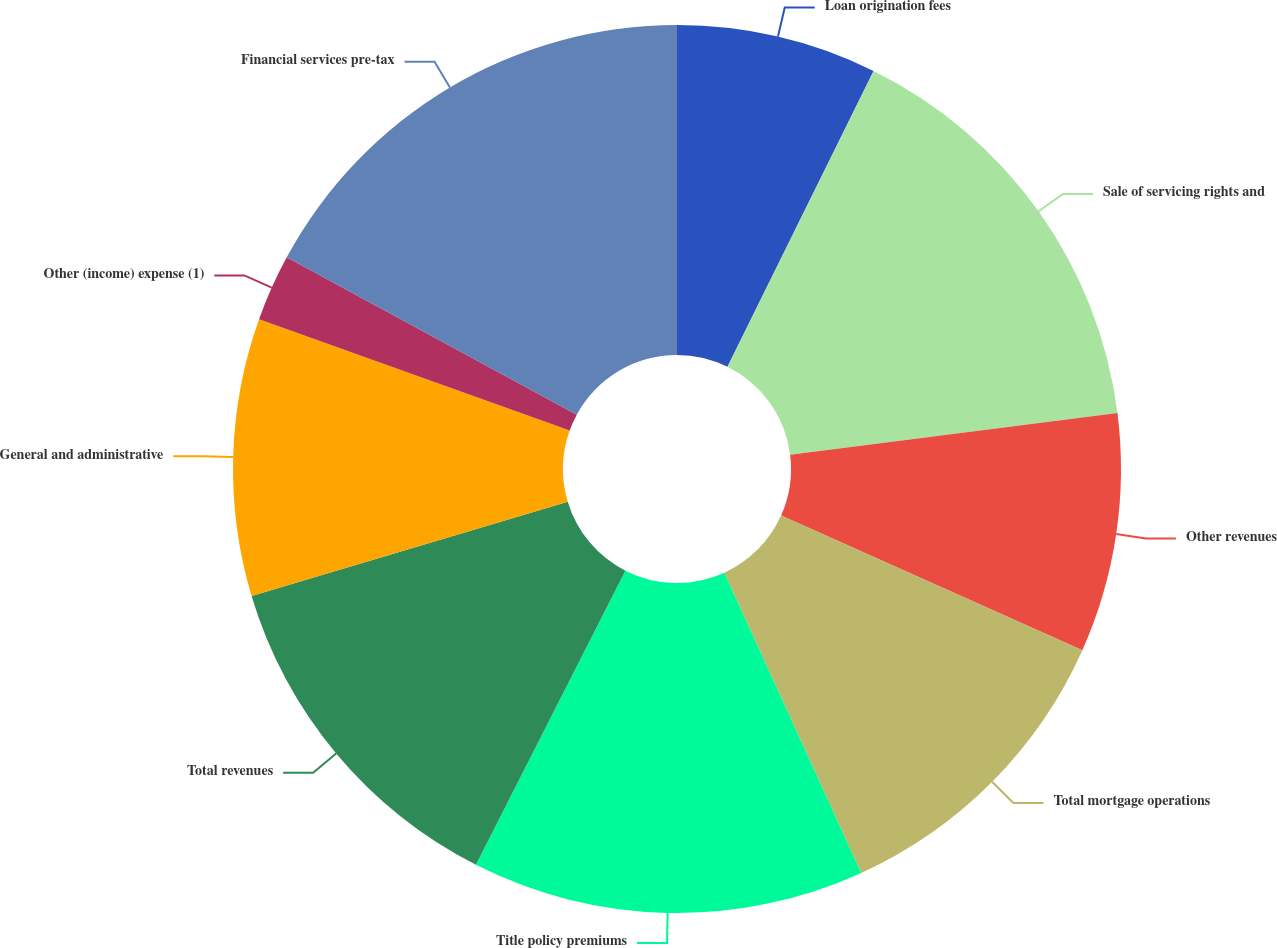<chart> <loc_0><loc_0><loc_500><loc_500><pie_chart><fcel>Loan origination fees<fcel>Sale of servicing rights and<fcel>Other revenues<fcel>Total mortgage operations<fcel>Title policy premiums<fcel>Total revenues<fcel>General and administrative<fcel>Other (income) expense (1)<fcel>Financial services pre-tax<nl><fcel>7.3%<fcel>15.69%<fcel>8.7%<fcel>11.5%<fcel>14.29%<fcel>12.9%<fcel>10.1%<fcel>2.43%<fcel>17.09%<nl></chart> 